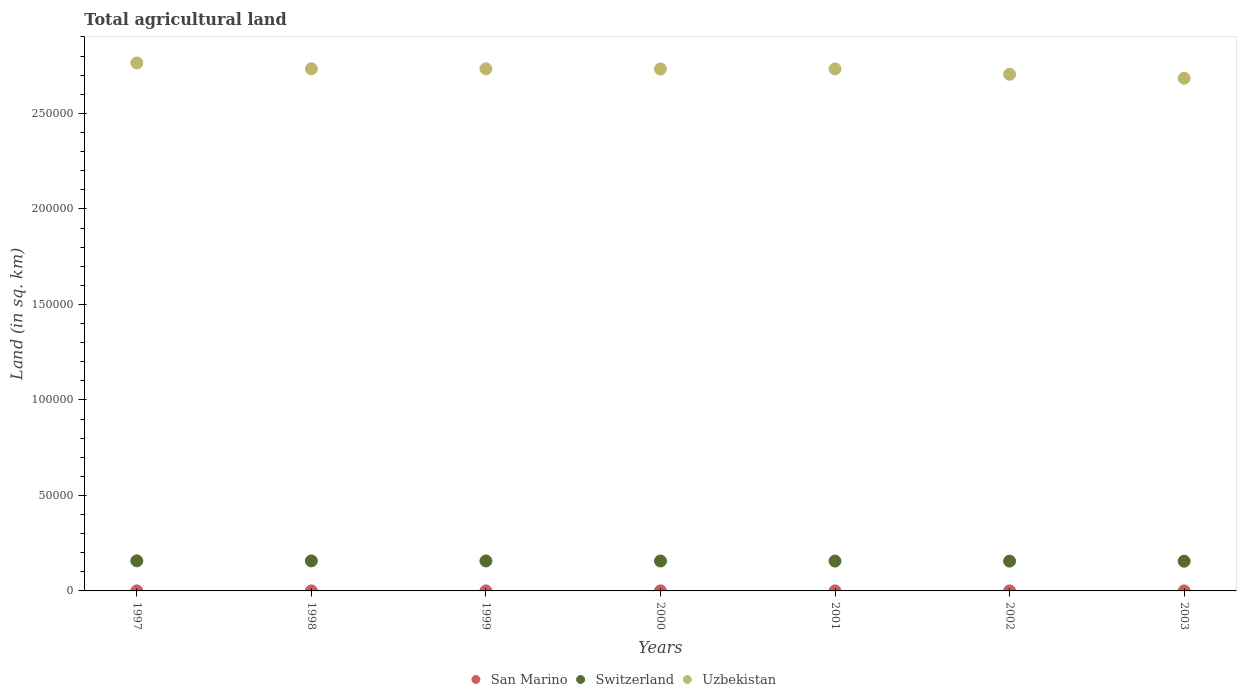Is the number of dotlines equal to the number of legend labels?
Offer a very short reply. Yes. What is the total agricultural land in San Marino in 2001?
Offer a terse response. 10. Across all years, what is the maximum total agricultural land in Uzbekistan?
Your answer should be compact. 2.76e+05. Across all years, what is the minimum total agricultural land in San Marino?
Keep it short and to the point. 10. In which year was the total agricultural land in Uzbekistan maximum?
Give a very brief answer. 1997. What is the total total agricultural land in San Marino in the graph?
Offer a terse response. 70. What is the difference between the total agricultural land in San Marino in 2000 and that in 2001?
Offer a terse response. 0. What is the difference between the total agricultural land in Switzerland in 2002 and the total agricultural land in Uzbekistan in 1997?
Give a very brief answer. -2.61e+05. What is the average total agricultural land in Switzerland per year?
Your response must be concise. 1.57e+04. In the year 2002, what is the difference between the total agricultural land in Uzbekistan and total agricultural land in Switzerland?
Provide a succinct answer. 2.55e+05. In how many years, is the total agricultural land in Switzerland greater than 240000 sq.km?
Offer a terse response. 0. What is the ratio of the total agricultural land in San Marino in 2000 to that in 2001?
Your answer should be compact. 1. Is the difference between the total agricultural land in Uzbekistan in 2000 and 2003 greater than the difference between the total agricultural land in Switzerland in 2000 and 2003?
Your answer should be compact. Yes. What is the difference between the highest and the lowest total agricultural land in San Marino?
Offer a very short reply. 0. In how many years, is the total agricultural land in San Marino greater than the average total agricultural land in San Marino taken over all years?
Your response must be concise. 0. Is the total agricultural land in San Marino strictly greater than the total agricultural land in Uzbekistan over the years?
Your answer should be very brief. No. What is the difference between two consecutive major ticks on the Y-axis?
Your answer should be very brief. 5.00e+04. Does the graph contain any zero values?
Provide a short and direct response. No. Where does the legend appear in the graph?
Ensure brevity in your answer.  Bottom center. How many legend labels are there?
Make the answer very short. 3. How are the legend labels stacked?
Give a very brief answer. Horizontal. What is the title of the graph?
Give a very brief answer. Total agricultural land. Does "Nepal" appear as one of the legend labels in the graph?
Provide a short and direct response. No. What is the label or title of the X-axis?
Your response must be concise. Years. What is the label or title of the Y-axis?
Ensure brevity in your answer.  Land (in sq. km). What is the Land (in sq. km) of Switzerland in 1997?
Make the answer very short. 1.58e+04. What is the Land (in sq. km) in Uzbekistan in 1997?
Your response must be concise. 2.76e+05. What is the Land (in sq. km) of San Marino in 1998?
Your answer should be compact. 10. What is the Land (in sq. km) in Switzerland in 1998?
Offer a very short reply. 1.57e+04. What is the Land (in sq. km) of Uzbekistan in 1998?
Provide a succinct answer. 2.73e+05. What is the Land (in sq. km) in Switzerland in 1999?
Keep it short and to the point. 1.57e+04. What is the Land (in sq. km) in Uzbekistan in 1999?
Make the answer very short. 2.73e+05. What is the Land (in sq. km) in Switzerland in 2000?
Ensure brevity in your answer.  1.57e+04. What is the Land (in sq. km) of Uzbekistan in 2000?
Your answer should be compact. 2.73e+05. What is the Land (in sq. km) in San Marino in 2001?
Your answer should be compact. 10. What is the Land (in sq. km) in Switzerland in 2001?
Your response must be concise. 1.56e+04. What is the Land (in sq. km) in Uzbekistan in 2001?
Your answer should be compact. 2.73e+05. What is the Land (in sq. km) of Switzerland in 2002?
Ensure brevity in your answer.  1.56e+04. What is the Land (in sq. km) of Uzbekistan in 2002?
Make the answer very short. 2.70e+05. What is the Land (in sq. km) in San Marino in 2003?
Your response must be concise. 10. What is the Land (in sq. km) in Switzerland in 2003?
Your response must be concise. 1.56e+04. What is the Land (in sq. km) in Uzbekistan in 2003?
Your answer should be compact. 2.68e+05. Across all years, what is the maximum Land (in sq. km) in San Marino?
Offer a very short reply. 10. Across all years, what is the maximum Land (in sq. km) in Switzerland?
Offer a terse response. 1.58e+04. Across all years, what is the maximum Land (in sq. km) of Uzbekistan?
Offer a terse response. 2.76e+05. Across all years, what is the minimum Land (in sq. km) of Switzerland?
Offer a very short reply. 1.56e+04. Across all years, what is the minimum Land (in sq. km) in Uzbekistan?
Offer a very short reply. 2.68e+05. What is the total Land (in sq. km) of San Marino in the graph?
Provide a short and direct response. 70. What is the total Land (in sq. km) of Switzerland in the graph?
Provide a succinct answer. 1.10e+05. What is the total Land (in sq. km) of Uzbekistan in the graph?
Your response must be concise. 1.91e+06. What is the difference between the Land (in sq. km) in Uzbekistan in 1997 and that in 1998?
Your answer should be compact. 3030. What is the difference between the Land (in sq. km) in Switzerland in 1997 and that in 1999?
Offer a terse response. 66. What is the difference between the Land (in sq. km) of Uzbekistan in 1997 and that in 1999?
Make the answer very short. 3070. What is the difference between the Land (in sq. km) in Switzerland in 1997 and that in 2000?
Offer a very short reply. 97. What is the difference between the Land (in sq. km) of Uzbekistan in 1997 and that in 2000?
Your answer should be very brief. 3150. What is the difference between the Land (in sq. km) of Switzerland in 1997 and that in 2001?
Keep it short and to the point. 131. What is the difference between the Land (in sq. km) in Uzbekistan in 1997 and that in 2001?
Offer a terse response. 3100. What is the difference between the Land (in sq. km) of San Marino in 1997 and that in 2002?
Offer a very short reply. 0. What is the difference between the Land (in sq. km) in Switzerland in 1997 and that in 2002?
Your response must be concise. 162. What is the difference between the Land (in sq. km) in Uzbekistan in 1997 and that in 2002?
Offer a very short reply. 5940. What is the difference between the Land (in sq. km) of San Marino in 1997 and that in 2003?
Your answer should be very brief. 0. What is the difference between the Land (in sq. km) of Switzerland in 1997 and that in 2003?
Offer a terse response. 195. What is the difference between the Land (in sq. km) of Uzbekistan in 1997 and that in 2003?
Give a very brief answer. 8000. What is the difference between the Land (in sq. km) in Switzerland in 1998 and that in 1999?
Keep it short and to the point. 32. What is the difference between the Land (in sq. km) in San Marino in 1998 and that in 2000?
Your answer should be compact. 0. What is the difference between the Land (in sq. km) of Uzbekistan in 1998 and that in 2000?
Provide a short and direct response. 120. What is the difference between the Land (in sq. km) of Switzerland in 1998 and that in 2001?
Your response must be concise. 97. What is the difference between the Land (in sq. km) of Uzbekistan in 1998 and that in 2001?
Your answer should be very brief. 70. What is the difference between the Land (in sq. km) of San Marino in 1998 and that in 2002?
Your answer should be very brief. 0. What is the difference between the Land (in sq. km) in Switzerland in 1998 and that in 2002?
Your answer should be compact. 128. What is the difference between the Land (in sq. km) of Uzbekistan in 1998 and that in 2002?
Provide a succinct answer. 2910. What is the difference between the Land (in sq. km) in San Marino in 1998 and that in 2003?
Give a very brief answer. 0. What is the difference between the Land (in sq. km) of Switzerland in 1998 and that in 2003?
Give a very brief answer. 161. What is the difference between the Land (in sq. km) in Uzbekistan in 1998 and that in 2003?
Ensure brevity in your answer.  4970. What is the difference between the Land (in sq. km) in Switzerland in 1999 and that in 2000?
Make the answer very short. 31. What is the difference between the Land (in sq. km) of Uzbekistan in 1999 and that in 2000?
Your response must be concise. 80. What is the difference between the Land (in sq. km) in San Marino in 1999 and that in 2001?
Offer a very short reply. 0. What is the difference between the Land (in sq. km) in San Marino in 1999 and that in 2002?
Make the answer very short. 0. What is the difference between the Land (in sq. km) in Switzerland in 1999 and that in 2002?
Your response must be concise. 96. What is the difference between the Land (in sq. km) in Uzbekistan in 1999 and that in 2002?
Offer a terse response. 2870. What is the difference between the Land (in sq. km) of San Marino in 1999 and that in 2003?
Make the answer very short. 0. What is the difference between the Land (in sq. km) in Switzerland in 1999 and that in 2003?
Provide a short and direct response. 129. What is the difference between the Land (in sq. km) in Uzbekistan in 1999 and that in 2003?
Your response must be concise. 4930. What is the difference between the Land (in sq. km) of San Marino in 2000 and that in 2001?
Ensure brevity in your answer.  0. What is the difference between the Land (in sq. km) of Switzerland in 2000 and that in 2001?
Your answer should be compact. 34. What is the difference between the Land (in sq. km) in Uzbekistan in 2000 and that in 2001?
Your response must be concise. -50. What is the difference between the Land (in sq. km) in San Marino in 2000 and that in 2002?
Give a very brief answer. 0. What is the difference between the Land (in sq. km) of Uzbekistan in 2000 and that in 2002?
Offer a very short reply. 2790. What is the difference between the Land (in sq. km) in San Marino in 2000 and that in 2003?
Give a very brief answer. 0. What is the difference between the Land (in sq. km) in Switzerland in 2000 and that in 2003?
Provide a short and direct response. 98. What is the difference between the Land (in sq. km) in Uzbekistan in 2000 and that in 2003?
Ensure brevity in your answer.  4850. What is the difference between the Land (in sq. km) of San Marino in 2001 and that in 2002?
Provide a succinct answer. 0. What is the difference between the Land (in sq. km) of Uzbekistan in 2001 and that in 2002?
Offer a terse response. 2840. What is the difference between the Land (in sq. km) of San Marino in 2001 and that in 2003?
Your response must be concise. 0. What is the difference between the Land (in sq. km) of Switzerland in 2001 and that in 2003?
Your response must be concise. 64. What is the difference between the Land (in sq. km) of Uzbekistan in 2001 and that in 2003?
Offer a terse response. 4900. What is the difference between the Land (in sq. km) of Uzbekistan in 2002 and that in 2003?
Provide a short and direct response. 2060. What is the difference between the Land (in sq. km) of San Marino in 1997 and the Land (in sq. km) of Switzerland in 1998?
Your answer should be very brief. -1.57e+04. What is the difference between the Land (in sq. km) in San Marino in 1997 and the Land (in sq. km) in Uzbekistan in 1998?
Your answer should be compact. -2.73e+05. What is the difference between the Land (in sq. km) in Switzerland in 1997 and the Land (in sq. km) in Uzbekistan in 1998?
Provide a succinct answer. -2.58e+05. What is the difference between the Land (in sq. km) of San Marino in 1997 and the Land (in sq. km) of Switzerland in 1999?
Your answer should be compact. -1.57e+04. What is the difference between the Land (in sq. km) in San Marino in 1997 and the Land (in sq. km) in Uzbekistan in 1999?
Provide a succinct answer. -2.73e+05. What is the difference between the Land (in sq. km) in Switzerland in 1997 and the Land (in sq. km) in Uzbekistan in 1999?
Offer a very short reply. -2.58e+05. What is the difference between the Land (in sq. km) in San Marino in 1997 and the Land (in sq. km) in Switzerland in 2000?
Offer a very short reply. -1.56e+04. What is the difference between the Land (in sq. km) in San Marino in 1997 and the Land (in sq. km) in Uzbekistan in 2000?
Provide a succinct answer. -2.73e+05. What is the difference between the Land (in sq. km) in Switzerland in 1997 and the Land (in sq. km) in Uzbekistan in 2000?
Provide a succinct answer. -2.57e+05. What is the difference between the Land (in sq. km) of San Marino in 1997 and the Land (in sq. km) of Switzerland in 2001?
Keep it short and to the point. -1.56e+04. What is the difference between the Land (in sq. km) of San Marino in 1997 and the Land (in sq. km) of Uzbekistan in 2001?
Your response must be concise. -2.73e+05. What is the difference between the Land (in sq. km) in Switzerland in 1997 and the Land (in sq. km) in Uzbekistan in 2001?
Provide a short and direct response. -2.58e+05. What is the difference between the Land (in sq. km) of San Marino in 1997 and the Land (in sq. km) of Switzerland in 2002?
Provide a succinct answer. -1.56e+04. What is the difference between the Land (in sq. km) of San Marino in 1997 and the Land (in sq. km) of Uzbekistan in 2002?
Your answer should be compact. -2.70e+05. What is the difference between the Land (in sq. km) of Switzerland in 1997 and the Land (in sq. km) of Uzbekistan in 2002?
Provide a short and direct response. -2.55e+05. What is the difference between the Land (in sq. km) in San Marino in 1997 and the Land (in sq. km) in Switzerland in 2003?
Make the answer very short. -1.56e+04. What is the difference between the Land (in sq. km) of San Marino in 1997 and the Land (in sq. km) of Uzbekistan in 2003?
Provide a short and direct response. -2.68e+05. What is the difference between the Land (in sq. km) in Switzerland in 1997 and the Land (in sq. km) in Uzbekistan in 2003?
Provide a succinct answer. -2.53e+05. What is the difference between the Land (in sq. km) of San Marino in 1998 and the Land (in sq. km) of Switzerland in 1999?
Make the answer very short. -1.57e+04. What is the difference between the Land (in sq. km) in San Marino in 1998 and the Land (in sq. km) in Uzbekistan in 1999?
Ensure brevity in your answer.  -2.73e+05. What is the difference between the Land (in sq. km) in Switzerland in 1998 and the Land (in sq. km) in Uzbekistan in 1999?
Your answer should be very brief. -2.58e+05. What is the difference between the Land (in sq. km) in San Marino in 1998 and the Land (in sq. km) in Switzerland in 2000?
Keep it short and to the point. -1.56e+04. What is the difference between the Land (in sq. km) of San Marino in 1998 and the Land (in sq. km) of Uzbekistan in 2000?
Provide a succinct answer. -2.73e+05. What is the difference between the Land (in sq. km) in Switzerland in 1998 and the Land (in sq. km) in Uzbekistan in 2000?
Your answer should be compact. -2.58e+05. What is the difference between the Land (in sq. km) of San Marino in 1998 and the Land (in sq. km) of Switzerland in 2001?
Your answer should be compact. -1.56e+04. What is the difference between the Land (in sq. km) of San Marino in 1998 and the Land (in sq. km) of Uzbekistan in 2001?
Give a very brief answer. -2.73e+05. What is the difference between the Land (in sq. km) in Switzerland in 1998 and the Land (in sq. km) in Uzbekistan in 2001?
Keep it short and to the point. -2.58e+05. What is the difference between the Land (in sq. km) of San Marino in 1998 and the Land (in sq. km) of Switzerland in 2002?
Your answer should be very brief. -1.56e+04. What is the difference between the Land (in sq. km) in San Marino in 1998 and the Land (in sq. km) in Uzbekistan in 2002?
Make the answer very short. -2.70e+05. What is the difference between the Land (in sq. km) of Switzerland in 1998 and the Land (in sq. km) of Uzbekistan in 2002?
Provide a short and direct response. -2.55e+05. What is the difference between the Land (in sq. km) in San Marino in 1998 and the Land (in sq. km) in Switzerland in 2003?
Your answer should be compact. -1.56e+04. What is the difference between the Land (in sq. km) of San Marino in 1998 and the Land (in sq. km) of Uzbekistan in 2003?
Provide a short and direct response. -2.68e+05. What is the difference between the Land (in sq. km) of Switzerland in 1998 and the Land (in sq. km) of Uzbekistan in 2003?
Your answer should be compact. -2.53e+05. What is the difference between the Land (in sq. km) of San Marino in 1999 and the Land (in sq. km) of Switzerland in 2000?
Your answer should be very brief. -1.56e+04. What is the difference between the Land (in sq. km) of San Marino in 1999 and the Land (in sq. km) of Uzbekistan in 2000?
Ensure brevity in your answer.  -2.73e+05. What is the difference between the Land (in sq. km) of Switzerland in 1999 and the Land (in sq. km) of Uzbekistan in 2000?
Keep it short and to the point. -2.58e+05. What is the difference between the Land (in sq. km) of San Marino in 1999 and the Land (in sq. km) of Switzerland in 2001?
Offer a terse response. -1.56e+04. What is the difference between the Land (in sq. km) in San Marino in 1999 and the Land (in sq. km) in Uzbekistan in 2001?
Your answer should be very brief. -2.73e+05. What is the difference between the Land (in sq. km) of Switzerland in 1999 and the Land (in sq. km) of Uzbekistan in 2001?
Ensure brevity in your answer.  -2.58e+05. What is the difference between the Land (in sq. km) in San Marino in 1999 and the Land (in sq. km) in Switzerland in 2002?
Make the answer very short. -1.56e+04. What is the difference between the Land (in sq. km) of San Marino in 1999 and the Land (in sq. km) of Uzbekistan in 2002?
Keep it short and to the point. -2.70e+05. What is the difference between the Land (in sq. km) in Switzerland in 1999 and the Land (in sq. km) in Uzbekistan in 2002?
Your answer should be compact. -2.55e+05. What is the difference between the Land (in sq. km) of San Marino in 1999 and the Land (in sq. km) of Switzerland in 2003?
Offer a terse response. -1.56e+04. What is the difference between the Land (in sq. km) in San Marino in 1999 and the Land (in sq. km) in Uzbekistan in 2003?
Provide a succinct answer. -2.68e+05. What is the difference between the Land (in sq. km) in Switzerland in 1999 and the Land (in sq. km) in Uzbekistan in 2003?
Offer a terse response. -2.53e+05. What is the difference between the Land (in sq. km) of San Marino in 2000 and the Land (in sq. km) of Switzerland in 2001?
Provide a succinct answer. -1.56e+04. What is the difference between the Land (in sq. km) of San Marino in 2000 and the Land (in sq. km) of Uzbekistan in 2001?
Keep it short and to the point. -2.73e+05. What is the difference between the Land (in sq. km) in Switzerland in 2000 and the Land (in sq. km) in Uzbekistan in 2001?
Keep it short and to the point. -2.58e+05. What is the difference between the Land (in sq. km) in San Marino in 2000 and the Land (in sq. km) in Switzerland in 2002?
Your answer should be very brief. -1.56e+04. What is the difference between the Land (in sq. km) in San Marino in 2000 and the Land (in sq. km) in Uzbekistan in 2002?
Your answer should be very brief. -2.70e+05. What is the difference between the Land (in sq. km) in Switzerland in 2000 and the Land (in sq. km) in Uzbekistan in 2002?
Make the answer very short. -2.55e+05. What is the difference between the Land (in sq. km) of San Marino in 2000 and the Land (in sq. km) of Switzerland in 2003?
Your answer should be very brief. -1.56e+04. What is the difference between the Land (in sq. km) in San Marino in 2000 and the Land (in sq. km) in Uzbekistan in 2003?
Ensure brevity in your answer.  -2.68e+05. What is the difference between the Land (in sq. km) in Switzerland in 2000 and the Land (in sq. km) in Uzbekistan in 2003?
Your answer should be very brief. -2.53e+05. What is the difference between the Land (in sq. km) in San Marino in 2001 and the Land (in sq. km) in Switzerland in 2002?
Ensure brevity in your answer.  -1.56e+04. What is the difference between the Land (in sq. km) in San Marino in 2001 and the Land (in sq. km) in Uzbekistan in 2002?
Ensure brevity in your answer.  -2.70e+05. What is the difference between the Land (in sq. km) in Switzerland in 2001 and the Land (in sq. km) in Uzbekistan in 2002?
Keep it short and to the point. -2.55e+05. What is the difference between the Land (in sq. km) in San Marino in 2001 and the Land (in sq. km) in Switzerland in 2003?
Provide a succinct answer. -1.56e+04. What is the difference between the Land (in sq. km) in San Marino in 2001 and the Land (in sq. km) in Uzbekistan in 2003?
Your answer should be very brief. -2.68e+05. What is the difference between the Land (in sq. km) in Switzerland in 2001 and the Land (in sq. km) in Uzbekistan in 2003?
Keep it short and to the point. -2.53e+05. What is the difference between the Land (in sq. km) in San Marino in 2002 and the Land (in sq. km) in Switzerland in 2003?
Keep it short and to the point. -1.56e+04. What is the difference between the Land (in sq. km) in San Marino in 2002 and the Land (in sq. km) in Uzbekistan in 2003?
Keep it short and to the point. -2.68e+05. What is the difference between the Land (in sq. km) in Switzerland in 2002 and the Land (in sq. km) in Uzbekistan in 2003?
Make the answer very short. -2.53e+05. What is the average Land (in sq. km) of San Marino per year?
Provide a succinct answer. 10. What is the average Land (in sq. km) of Switzerland per year?
Your answer should be very brief. 1.57e+04. What is the average Land (in sq. km) in Uzbekistan per year?
Make the answer very short. 2.73e+05. In the year 1997, what is the difference between the Land (in sq. km) of San Marino and Land (in sq. km) of Switzerland?
Give a very brief answer. -1.57e+04. In the year 1997, what is the difference between the Land (in sq. km) in San Marino and Land (in sq. km) in Uzbekistan?
Keep it short and to the point. -2.76e+05. In the year 1997, what is the difference between the Land (in sq. km) in Switzerland and Land (in sq. km) in Uzbekistan?
Provide a short and direct response. -2.61e+05. In the year 1998, what is the difference between the Land (in sq. km) of San Marino and Land (in sq. km) of Switzerland?
Your response must be concise. -1.57e+04. In the year 1998, what is the difference between the Land (in sq. km) of San Marino and Land (in sq. km) of Uzbekistan?
Your answer should be very brief. -2.73e+05. In the year 1998, what is the difference between the Land (in sq. km) in Switzerland and Land (in sq. km) in Uzbekistan?
Your answer should be very brief. -2.58e+05. In the year 1999, what is the difference between the Land (in sq. km) of San Marino and Land (in sq. km) of Switzerland?
Your answer should be very brief. -1.57e+04. In the year 1999, what is the difference between the Land (in sq. km) in San Marino and Land (in sq. km) in Uzbekistan?
Offer a terse response. -2.73e+05. In the year 1999, what is the difference between the Land (in sq. km) in Switzerland and Land (in sq. km) in Uzbekistan?
Your response must be concise. -2.58e+05. In the year 2000, what is the difference between the Land (in sq. km) in San Marino and Land (in sq. km) in Switzerland?
Give a very brief answer. -1.56e+04. In the year 2000, what is the difference between the Land (in sq. km) of San Marino and Land (in sq. km) of Uzbekistan?
Provide a succinct answer. -2.73e+05. In the year 2000, what is the difference between the Land (in sq. km) of Switzerland and Land (in sq. km) of Uzbekistan?
Your response must be concise. -2.58e+05. In the year 2001, what is the difference between the Land (in sq. km) in San Marino and Land (in sq. km) in Switzerland?
Provide a succinct answer. -1.56e+04. In the year 2001, what is the difference between the Land (in sq. km) in San Marino and Land (in sq. km) in Uzbekistan?
Your answer should be very brief. -2.73e+05. In the year 2001, what is the difference between the Land (in sq. km) of Switzerland and Land (in sq. km) of Uzbekistan?
Provide a short and direct response. -2.58e+05. In the year 2002, what is the difference between the Land (in sq. km) in San Marino and Land (in sq. km) in Switzerland?
Your answer should be very brief. -1.56e+04. In the year 2002, what is the difference between the Land (in sq. km) in San Marino and Land (in sq. km) in Uzbekistan?
Your answer should be very brief. -2.70e+05. In the year 2002, what is the difference between the Land (in sq. km) in Switzerland and Land (in sq. km) in Uzbekistan?
Your answer should be compact. -2.55e+05. In the year 2003, what is the difference between the Land (in sq. km) in San Marino and Land (in sq. km) in Switzerland?
Your answer should be very brief. -1.56e+04. In the year 2003, what is the difference between the Land (in sq. km) of San Marino and Land (in sq. km) of Uzbekistan?
Provide a short and direct response. -2.68e+05. In the year 2003, what is the difference between the Land (in sq. km) in Switzerland and Land (in sq. km) in Uzbekistan?
Your answer should be compact. -2.53e+05. What is the ratio of the Land (in sq. km) of San Marino in 1997 to that in 1998?
Your answer should be compact. 1. What is the ratio of the Land (in sq. km) in Switzerland in 1997 to that in 1998?
Ensure brevity in your answer.  1. What is the ratio of the Land (in sq. km) of Uzbekistan in 1997 to that in 1998?
Keep it short and to the point. 1.01. What is the ratio of the Land (in sq. km) in San Marino in 1997 to that in 1999?
Your answer should be compact. 1. What is the ratio of the Land (in sq. km) in Switzerland in 1997 to that in 1999?
Provide a succinct answer. 1. What is the ratio of the Land (in sq. km) of Uzbekistan in 1997 to that in 1999?
Ensure brevity in your answer.  1.01. What is the ratio of the Land (in sq. km) of Switzerland in 1997 to that in 2000?
Offer a very short reply. 1.01. What is the ratio of the Land (in sq. km) in Uzbekistan in 1997 to that in 2000?
Ensure brevity in your answer.  1.01. What is the ratio of the Land (in sq. km) in San Marino in 1997 to that in 2001?
Your response must be concise. 1. What is the ratio of the Land (in sq. km) of Switzerland in 1997 to that in 2001?
Your answer should be very brief. 1.01. What is the ratio of the Land (in sq. km) of Uzbekistan in 1997 to that in 2001?
Offer a very short reply. 1.01. What is the ratio of the Land (in sq. km) in Switzerland in 1997 to that in 2002?
Provide a succinct answer. 1.01. What is the ratio of the Land (in sq. km) in Uzbekistan in 1997 to that in 2002?
Keep it short and to the point. 1.02. What is the ratio of the Land (in sq. km) in Switzerland in 1997 to that in 2003?
Keep it short and to the point. 1.01. What is the ratio of the Land (in sq. km) in Uzbekistan in 1997 to that in 2003?
Give a very brief answer. 1.03. What is the ratio of the Land (in sq. km) in San Marino in 1998 to that in 1999?
Give a very brief answer. 1. What is the ratio of the Land (in sq. km) of San Marino in 1998 to that in 2000?
Provide a short and direct response. 1. What is the ratio of the Land (in sq. km) in Switzerland in 1998 to that in 2000?
Offer a terse response. 1. What is the ratio of the Land (in sq. km) of Uzbekistan in 1998 to that in 2000?
Keep it short and to the point. 1. What is the ratio of the Land (in sq. km) of Switzerland in 1998 to that in 2001?
Offer a very short reply. 1.01. What is the ratio of the Land (in sq. km) of Uzbekistan in 1998 to that in 2001?
Your answer should be compact. 1. What is the ratio of the Land (in sq. km) in Switzerland in 1998 to that in 2002?
Provide a short and direct response. 1.01. What is the ratio of the Land (in sq. km) of Uzbekistan in 1998 to that in 2002?
Offer a very short reply. 1.01. What is the ratio of the Land (in sq. km) of San Marino in 1998 to that in 2003?
Your response must be concise. 1. What is the ratio of the Land (in sq. km) in Switzerland in 1998 to that in 2003?
Give a very brief answer. 1.01. What is the ratio of the Land (in sq. km) of Uzbekistan in 1998 to that in 2003?
Give a very brief answer. 1.02. What is the ratio of the Land (in sq. km) in San Marino in 1999 to that in 2000?
Your response must be concise. 1. What is the ratio of the Land (in sq. km) of San Marino in 1999 to that in 2001?
Give a very brief answer. 1. What is the ratio of the Land (in sq. km) in Switzerland in 1999 to that in 2001?
Offer a terse response. 1. What is the ratio of the Land (in sq. km) of Uzbekistan in 1999 to that in 2002?
Make the answer very short. 1.01. What is the ratio of the Land (in sq. km) of San Marino in 1999 to that in 2003?
Offer a very short reply. 1. What is the ratio of the Land (in sq. km) of Switzerland in 1999 to that in 2003?
Give a very brief answer. 1.01. What is the ratio of the Land (in sq. km) of Uzbekistan in 1999 to that in 2003?
Give a very brief answer. 1.02. What is the ratio of the Land (in sq. km) of Switzerland in 2000 to that in 2001?
Ensure brevity in your answer.  1. What is the ratio of the Land (in sq. km) in Uzbekistan in 2000 to that in 2001?
Your answer should be compact. 1. What is the ratio of the Land (in sq. km) in Switzerland in 2000 to that in 2002?
Keep it short and to the point. 1. What is the ratio of the Land (in sq. km) in Uzbekistan in 2000 to that in 2002?
Provide a succinct answer. 1.01. What is the ratio of the Land (in sq. km) of Uzbekistan in 2000 to that in 2003?
Offer a terse response. 1.02. What is the ratio of the Land (in sq. km) of Switzerland in 2001 to that in 2002?
Give a very brief answer. 1. What is the ratio of the Land (in sq. km) in Uzbekistan in 2001 to that in 2002?
Offer a terse response. 1.01. What is the ratio of the Land (in sq. km) of San Marino in 2001 to that in 2003?
Your answer should be compact. 1. What is the ratio of the Land (in sq. km) in Switzerland in 2001 to that in 2003?
Provide a short and direct response. 1. What is the ratio of the Land (in sq. km) of Uzbekistan in 2001 to that in 2003?
Make the answer very short. 1.02. What is the ratio of the Land (in sq. km) of Switzerland in 2002 to that in 2003?
Your response must be concise. 1. What is the ratio of the Land (in sq. km) in Uzbekistan in 2002 to that in 2003?
Provide a short and direct response. 1.01. What is the difference between the highest and the second highest Land (in sq. km) in Uzbekistan?
Give a very brief answer. 3030. What is the difference between the highest and the lowest Land (in sq. km) of Switzerland?
Ensure brevity in your answer.  195. What is the difference between the highest and the lowest Land (in sq. km) of Uzbekistan?
Provide a short and direct response. 8000. 